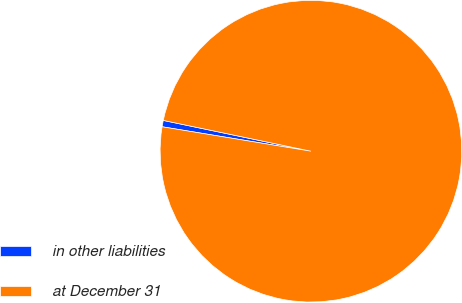Convert chart to OTSL. <chart><loc_0><loc_0><loc_500><loc_500><pie_chart><fcel>in other liabilities<fcel>at December 31<nl><fcel>0.68%<fcel>99.32%<nl></chart> 